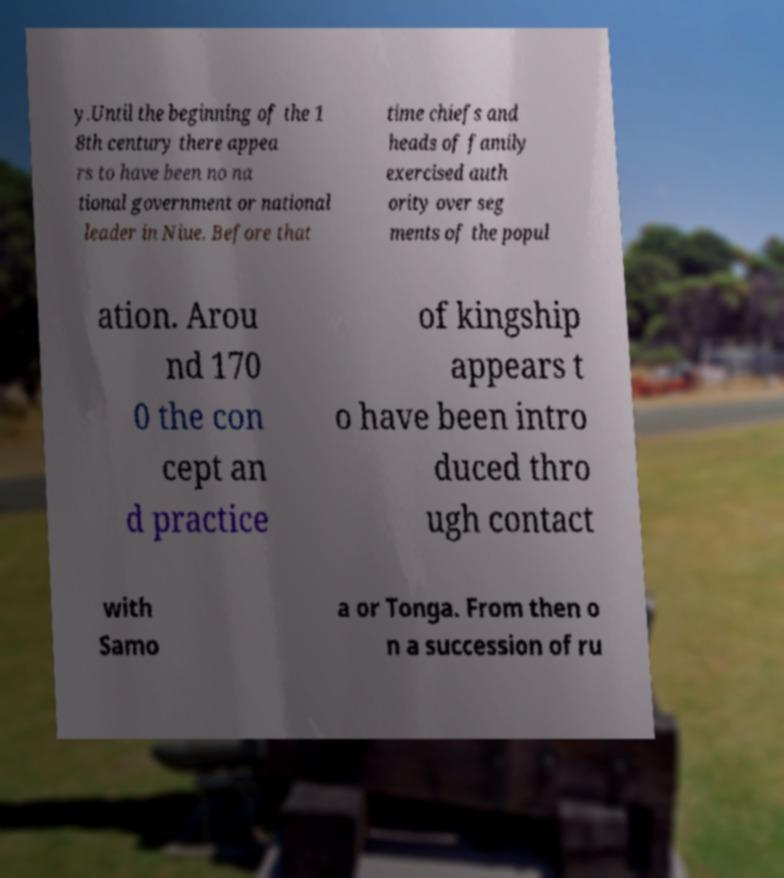Can you accurately transcribe the text from the provided image for me? y.Until the beginning of the 1 8th century there appea rs to have been no na tional government or national leader in Niue. Before that time chiefs and heads of family exercised auth ority over seg ments of the popul ation. Arou nd 170 0 the con cept an d practice of kingship appears t o have been intro duced thro ugh contact with Samo a or Tonga. From then o n a succession of ru 